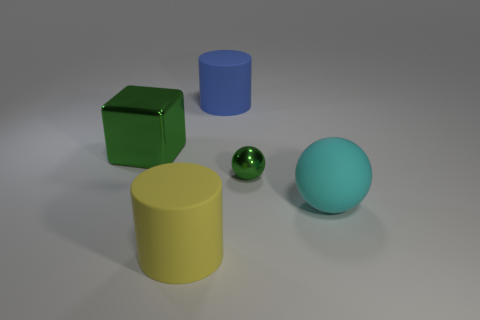Are there any large cyan things?
Ensure brevity in your answer.  Yes. How big is the thing in front of the ball that is in front of the small metallic thing right of the blue cylinder?
Provide a short and direct response. Large. What number of other objects are the same size as the metallic block?
Offer a terse response. 3. There is a matte object behind the cyan sphere; how big is it?
Your answer should be compact. Large. Is there anything else of the same color as the shiny ball?
Your answer should be very brief. Yes. Is the big cylinder in front of the small green shiny thing made of the same material as the blue cylinder?
Give a very brief answer. Yes. What number of things are in front of the big green object and left of the rubber sphere?
Your response must be concise. 2. What size is the cylinder that is behind the green thing to the left of the big yellow matte thing?
Keep it short and to the point. Large. Are there more yellow matte cylinders than tiny gray things?
Provide a short and direct response. Yes. Do the cylinder that is in front of the shiny block and the ball behind the large cyan object have the same color?
Provide a short and direct response. No. 